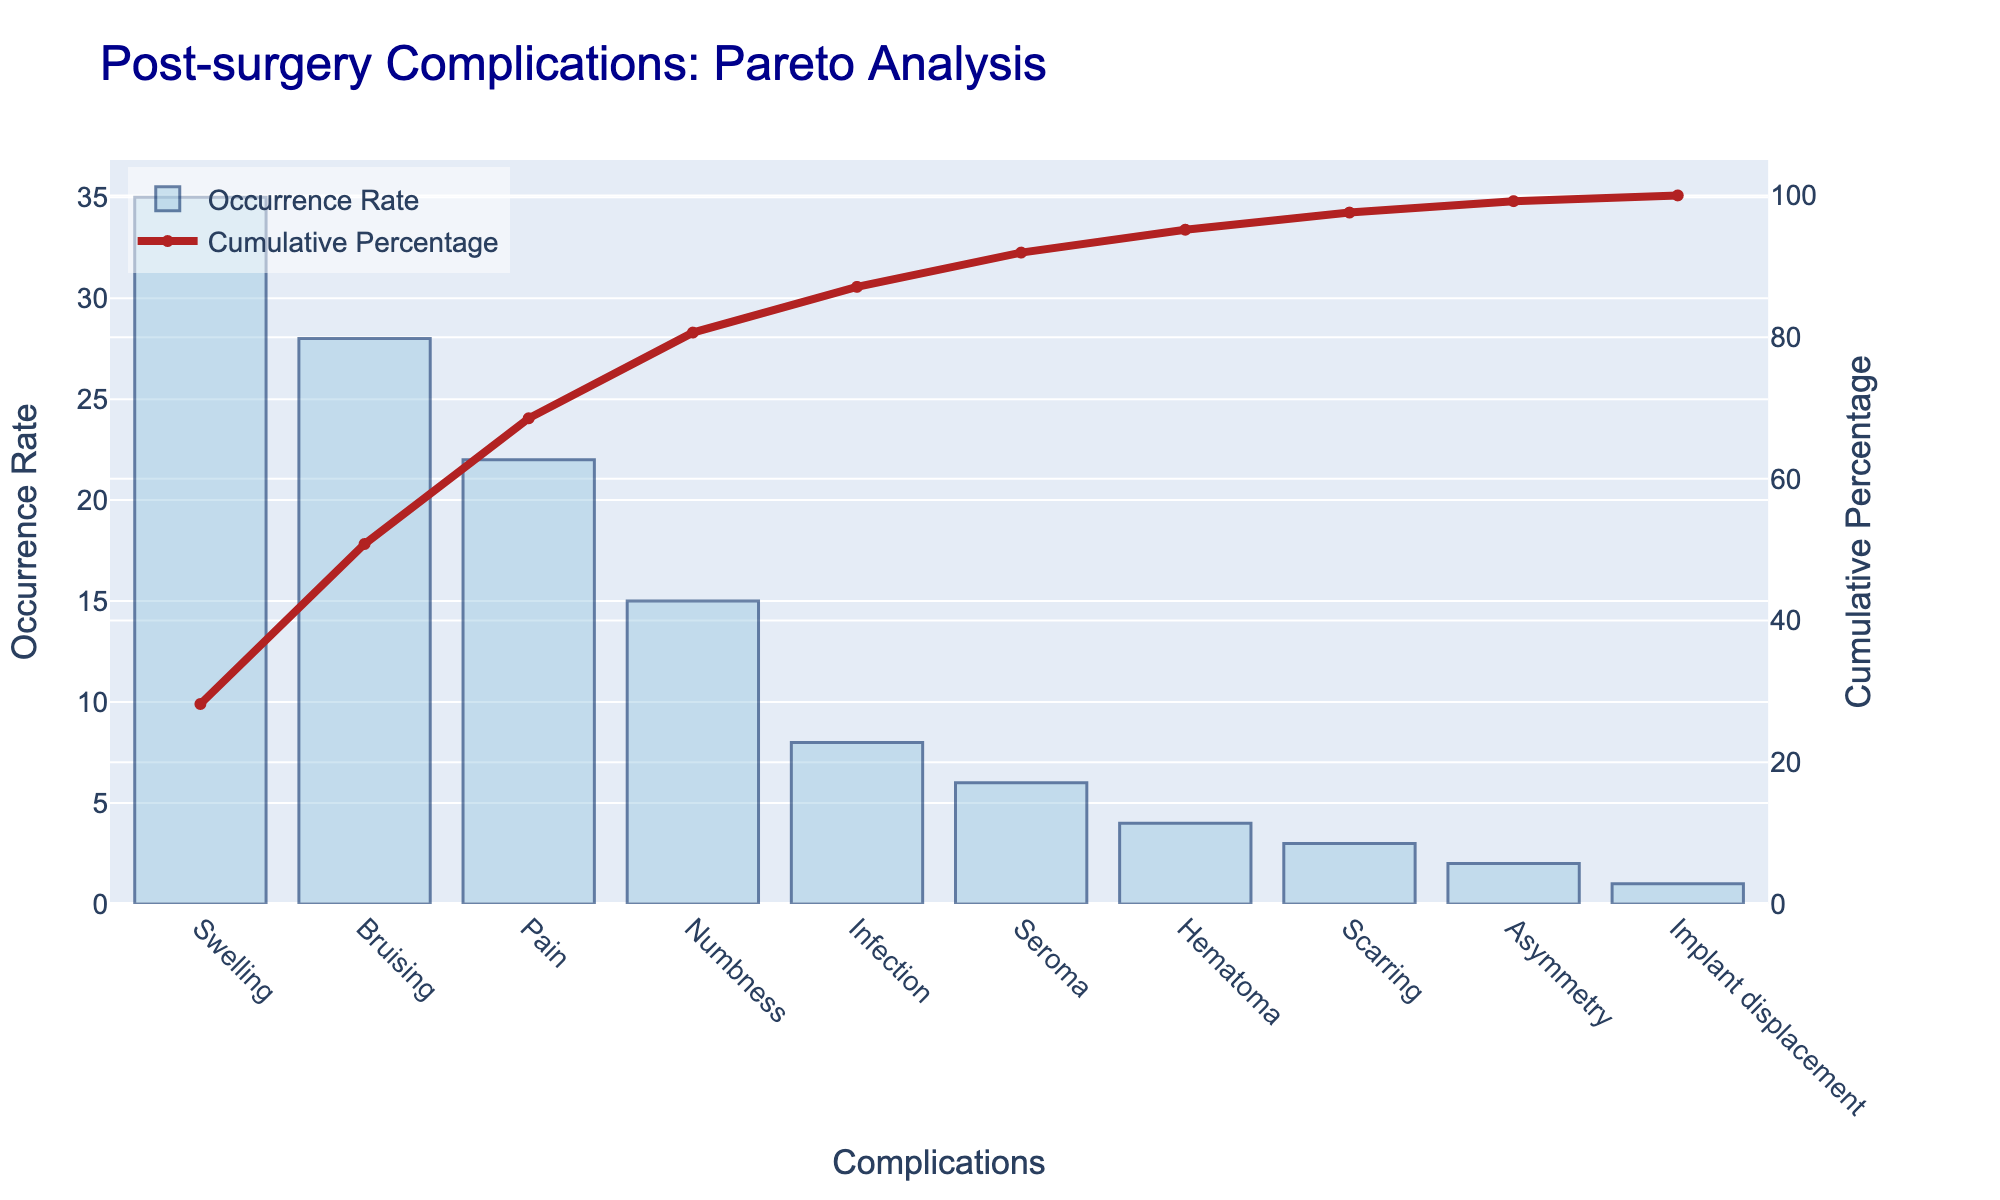What's the title of the figure? The title is usually displayed at the top of the figure in a larger and distinct font, making it easy to identify by looking at that area.
Answer: Post-surgery Complications: Pareto Analysis How many complications are listed in the chart? By counting all the distinct bars on the x-axis, you can determine the number of complications listed.
Answer: 10 Which complication has the highest occurrence rate? The bar with the greatest height corresponds to the complication with the highest occurrence rate. This will be the first bar on the left as the chart is sorted.
Answer: Swelling What is the cumulative percentage after including the top three complications? To find this, look at the cumulative percentage line's value above the third bar on the x-axis. These steps are: find the first three bars, then refer to the cumulative percentage values.
Answer: 85% How does the occurrence rate of Pain compare to Bruising? Compare the height of the bar for Pain with the height of the bar for Bruising to see which one is higher.
Answer: Pain is less than Bruising What is the cumulative percentage of complications after including Seroma? Locate the cumulative percentage value that corresponds with Seroma on the x-axis; it’s above the bar for Seroma.
Answer: 99% What is the difference in occurrence rate between Infection and Hematoma? To find this, subtract the occurrence rate of Hematoma from the occurrence rate of Infection. Look for their respective bars on the chart to get these values.
Answer: 8 - 4 = 4 What percentage of the total occurrence rate is contributed by Scarring, Asymmetry, and Implant displacement combined? Add the occurrence rates of Scarring, Asymmetry, and Implant displacement, then divide by the total occurrence rate. This total percentage can also be derived by looking at the cumulative percentage line after these complications. To detail: 3 + 2 + 1 = 6, 6 / 100 = 6%.
Answer: 6% Which complication is represented by the red line hitting approximately 50% cumulative percentage? Trace the cumulative line from the 50% point on the secondary y-axis to the corresponding complication on the x-axis.
Answer: Bruising How many complications have an occurrence rate less than or equal to 10%? Identify the bars that fall below or at the 10% mark on the primary y-axis and count them.
Answer: 5 